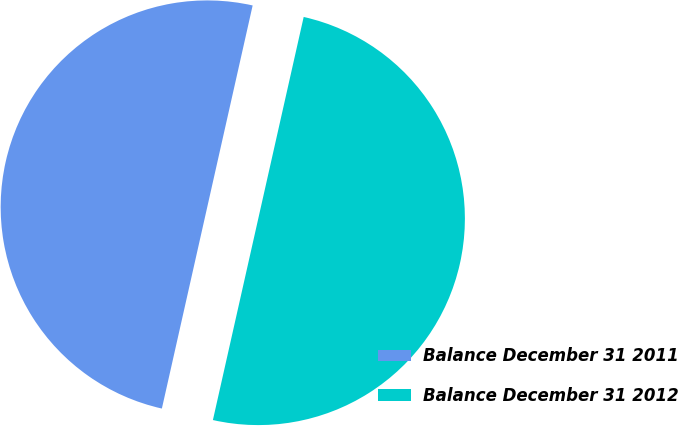Convert chart. <chart><loc_0><loc_0><loc_500><loc_500><pie_chart><fcel>Balance December 31 2011<fcel>Balance December 31 2012<nl><fcel>50.0%<fcel>50.0%<nl></chart> 